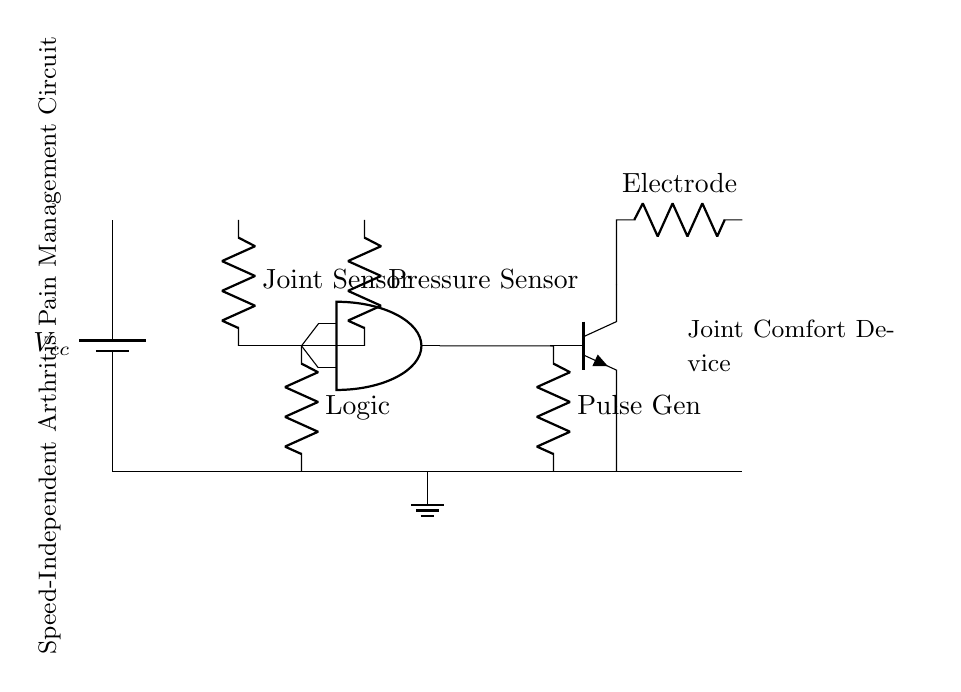what type of circuit is shown? The circuit is an asynchronous type, indicated by the presence of a Muller C-element and independent operation of the inputs without a common clock.
Answer: asynchronous what components are included in the circuit? The components are a battery, joint sensor, pressure sensor, logic resistor, Muller C-element, pulse generator, and an electrode. These are all identifiable from the diagram annotations.
Answer: battery, joint sensor, pressure sensor, logic resistor, Muller C-element, pulse generator, electrode how many sensors are used in this circuit? There are two sensors in the circuit, namely the joint sensor and the pressure sensor. They are both represented as resistors in the diagram.
Answer: 2 what is the function of the Muller C-element in this circuit? The Muller C-element acts as a combining logic gate that ensures the output signal is produced only when both inputs are satisfied, thus playing a key role in synchronizing the sensor outputs.
Answer: synchronization where does the output from the pulse generator connect in the circuit? The output from the pulse generator connects to the base of the npn transistor, which acts as the output stage leading to the electrode. This connection is indicated by the direct line following the pulse generator.
Answer: npn transistor 